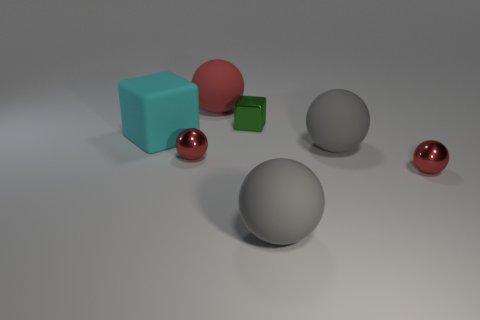Subtract all red matte spheres. How many spheres are left? 4 Subtract all blue cylinders. How many red spheres are left? 3 Add 3 red balls. How many objects exist? 10 Subtract all green blocks. How many blocks are left? 1 Subtract all balls. How many objects are left? 2 Add 2 green objects. How many green objects are left? 3 Add 5 tiny cyan metal cylinders. How many tiny cyan metal cylinders exist? 5 Subtract 1 cyan blocks. How many objects are left? 6 Subtract all green spheres. Subtract all red blocks. How many spheres are left? 5 Subtract all gray rubber spheres. Subtract all small cubes. How many objects are left? 4 